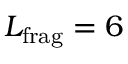<formula> <loc_0><loc_0><loc_500><loc_500>L _ { f r a g } = 6</formula> 